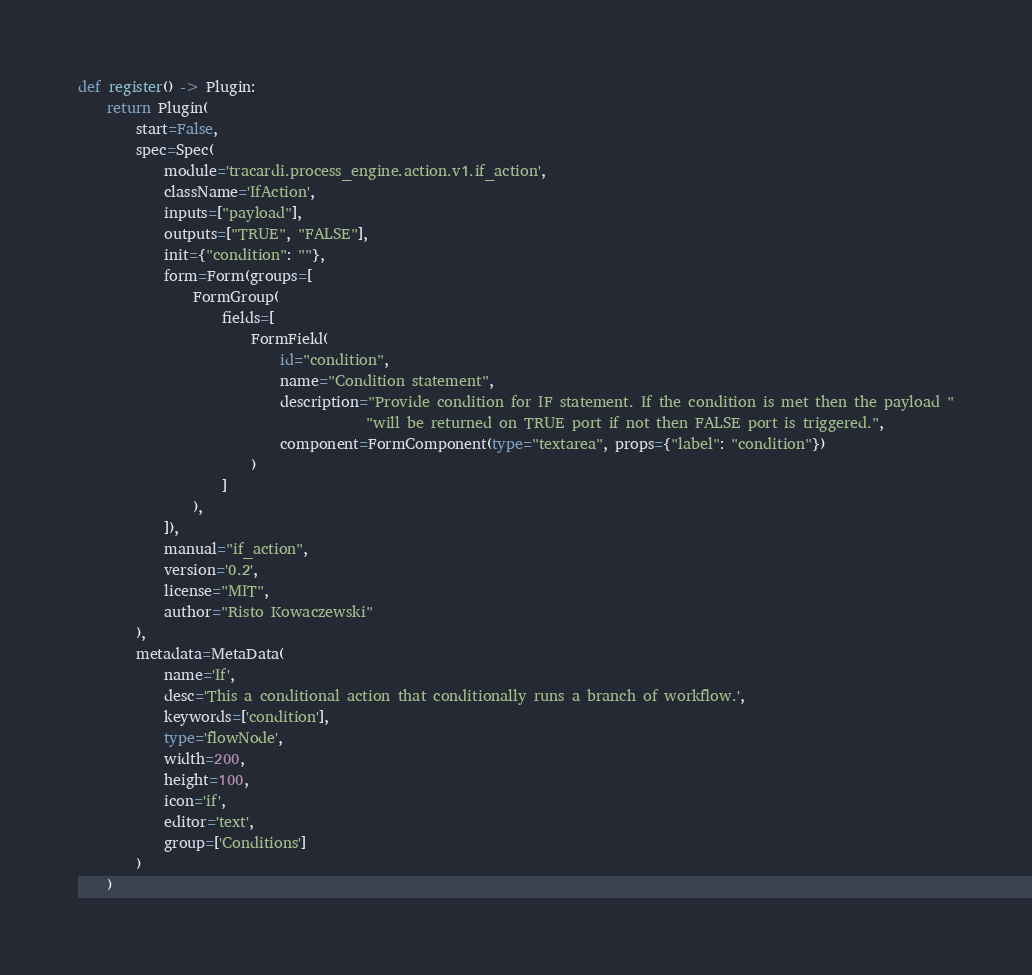<code> <loc_0><loc_0><loc_500><loc_500><_Python_>

def register() -> Plugin:
    return Plugin(
        start=False,
        spec=Spec(
            module='tracardi.process_engine.action.v1.if_action',
            className='IfAction',
            inputs=["payload"],
            outputs=["TRUE", "FALSE"],
            init={"condition": ""},
            form=Form(groups=[
                FormGroup(
                    fields=[
                        FormField(
                            id="condition",
                            name="Condition statement",
                            description="Provide condition for IF statement. If the condition is met then the payload "
                                        "will be returned on TRUE port if not then FALSE port is triggered.",
                            component=FormComponent(type="textarea", props={"label": "condition"})
                        )
                    ]
                ),
            ]),
            manual="if_action",
            version='0.2',
            license="MIT",
            author="Risto Kowaczewski"
        ),
        metadata=MetaData(
            name='If',
            desc='This a conditional action that conditionally runs a branch of workflow.',
            keywords=['condition'],
            type='flowNode',
            width=200,
            height=100,
            icon='if',
            editor='text',
            group=['Conditions']
        )
    )
</code> 